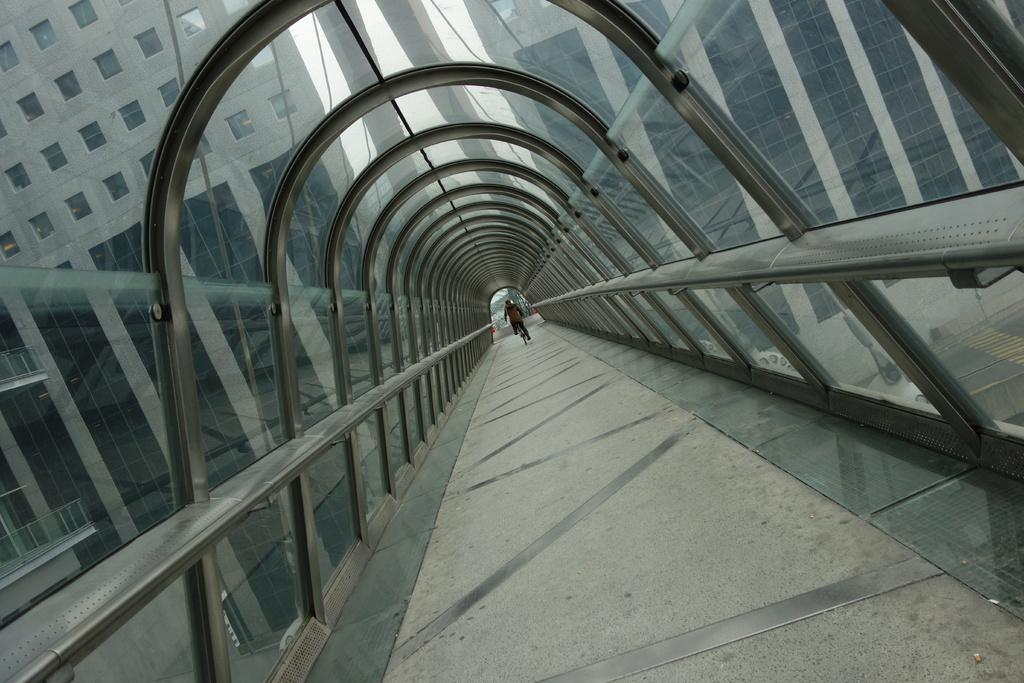What is the person in the image doing? The person is riding a bicycle. Where is the person riding the bicycle? The person is riding the bicycle on the floor. What type of structure is above the person and the bicycle? The floor is under a curved glass roof. What can be seen through the glass roof? Buildings, windows, a fence, and the sky are visible through the glass roof. What type of cheese is being used to build the fence visible through the glass roof? There is no cheese present in the image, and the fence is not made of cheese. 